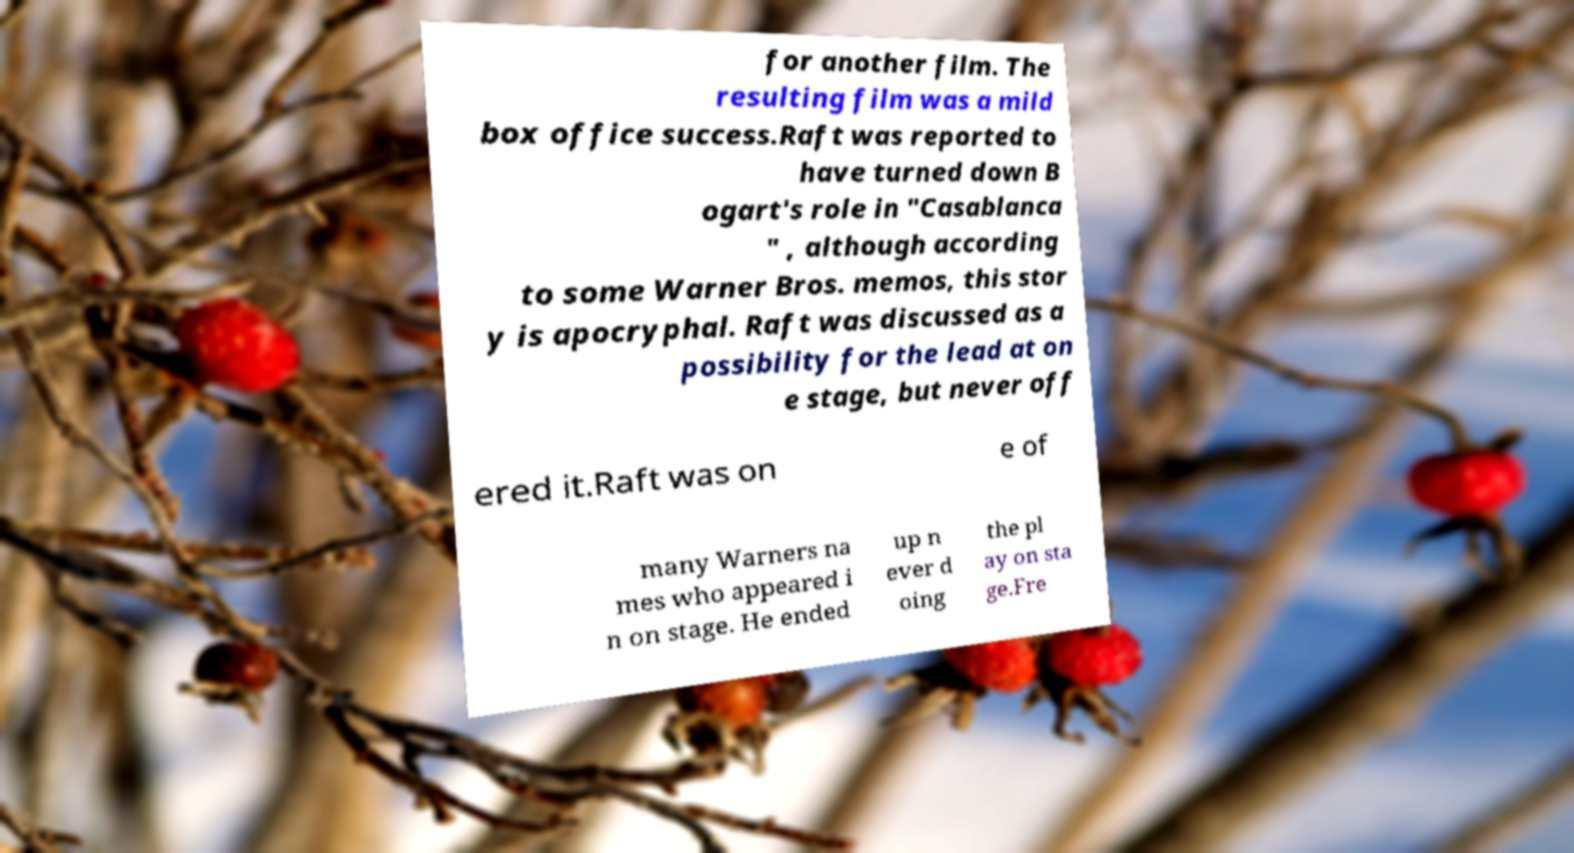Could you assist in decoding the text presented in this image and type it out clearly? for another film. The resulting film was a mild box office success.Raft was reported to have turned down B ogart's role in "Casablanca " , although according to some Warner Bros. memos, this stor y is apocryphal. Raft was discussed as a possibility for the lead at on e stage, but never off ered it.Raft was on e of many Warners na mes who appeared i n on stage. He ended up n ever d oing the pl ay on sta ge.Fre 